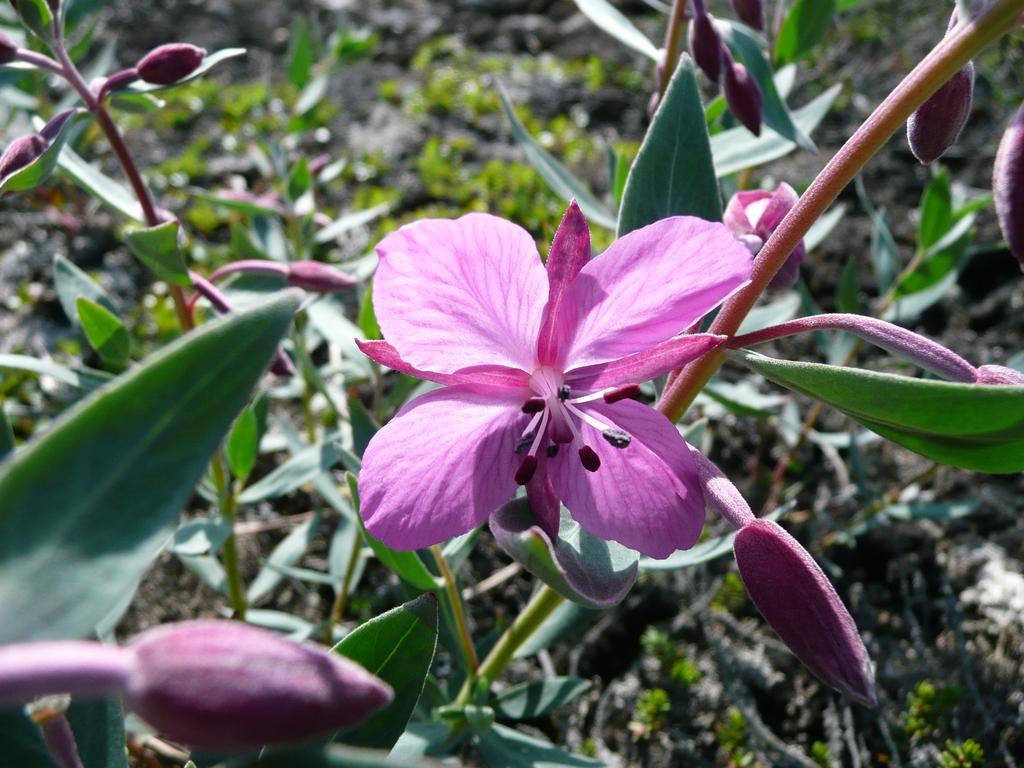How would you summarize this image in a sentence or two? In this image there are plants. There are leaves, flowers and buds to the stems. In the center there is a flower. There are pink petals to the flower. In the center of the flower there are pollen grains. 